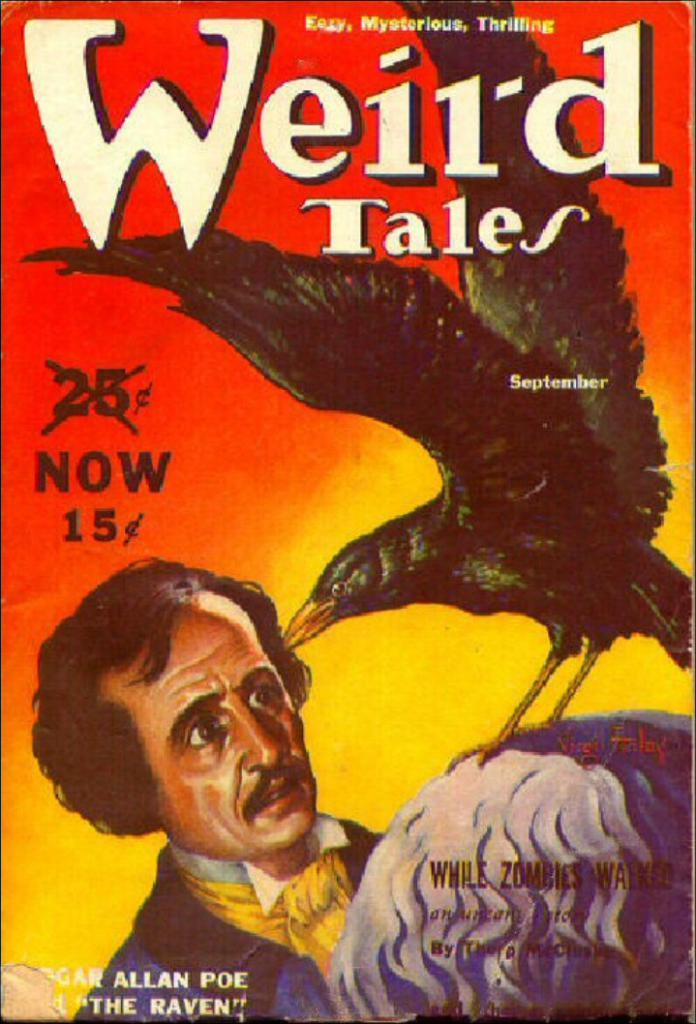<image>
Summarize the visual content of the image. A poster for Weird Tales by Edgar Allen Poe claiming a price drop to 15 cents. 